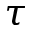Convert formula to latex. <formula><loc_0><loc_0><loc_500><loc_500>\tau</formula> 